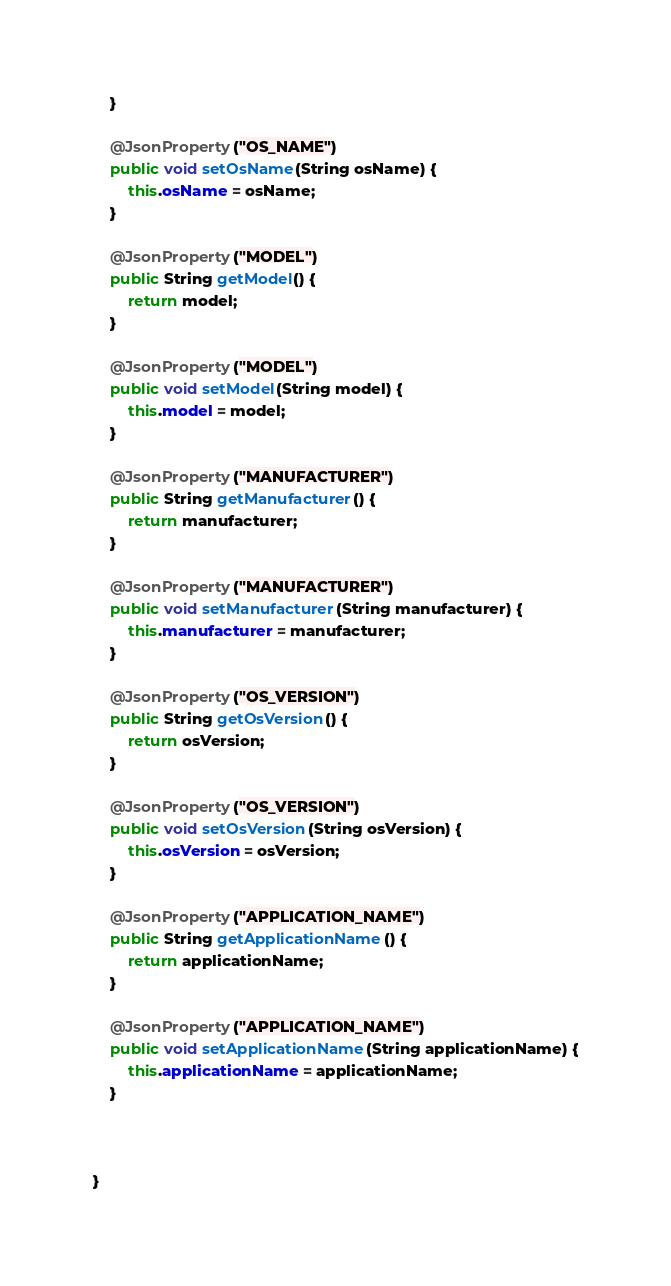Convert code to text. <code><loc_0><loc_0><loc_500><loc_500><_Java_>    }

    @JsonProperty("OS_NAME")
    public void setOsName(String osName) {
        this.osName = osName;
    }

    @JsonProperty("MODEL")
    public String getModel() {
        return model;
    }

    @JsonProperty("MODEL")
    public void setModel(String model) {
        this.model = model;
    }

    @JsonProperty("MANUFACTURER")
    public String getManufacturer() {
        return manufacturer;
    }

    @JsonProperty("MANUFACTURER")
    public void setManufacturer(String manufacturer) {
        this.manufacturer = manufacturer;
    }

    @JsonProperty("OS_VERSION")
    public String getOsVersion() {
        return osVersion;
    }

    @JsonProperty("OS_VERSION")
    public void setOsVersion(String osVersion) {
        this.osVersion = osVersion;
    }

    @JsonProperty("APPLICATION_NAME")
    public String getApplicationName() {
        return applicationName;
    }

    @JsonProperty("APPLICATION_NAME")
    public void setApplicationName(String applicationName) {
        this.applicationName = applicationName;
    }



}
</code> 